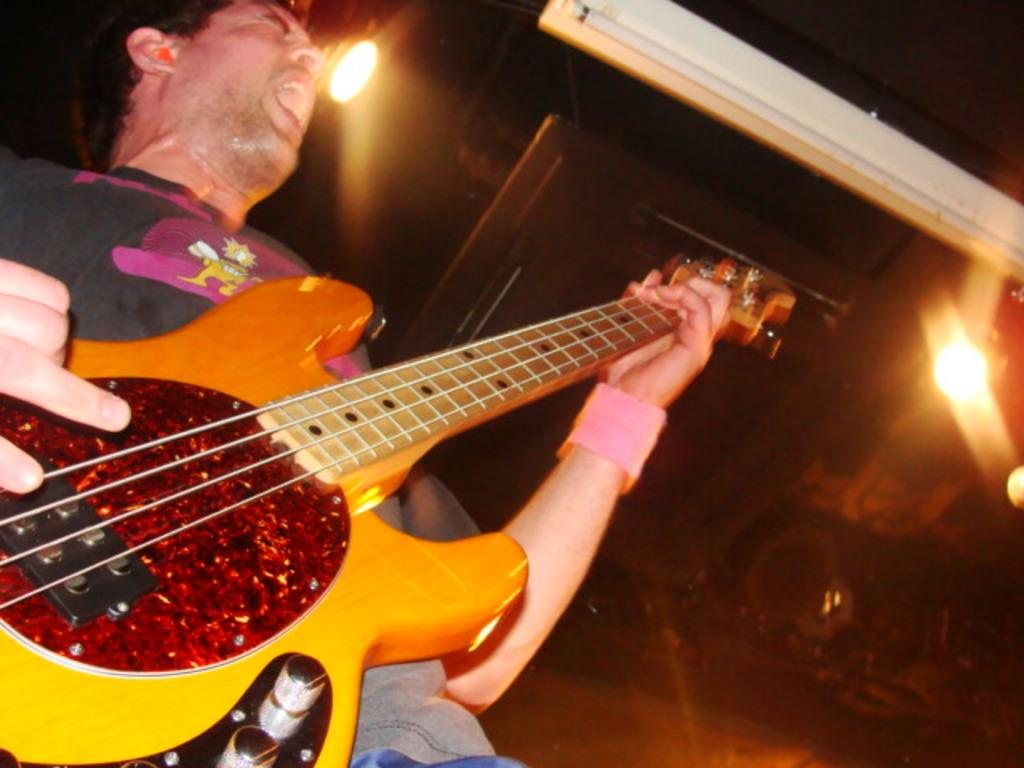What is the man in the image doing? The man is playing a guitar in the image. What can be seen in the background of the image? There are lights visible in the image. What is the surface on which the man is standing? The image shows a floor. What type of body language does the man exhibit while playing the guitar? The image does not show the man's body language, only that he is playing a guitar. How does the man express his feelings of hate towards the guitar in the image? There is no indication in the image that the man has any feelings of hate towards the guitar. 